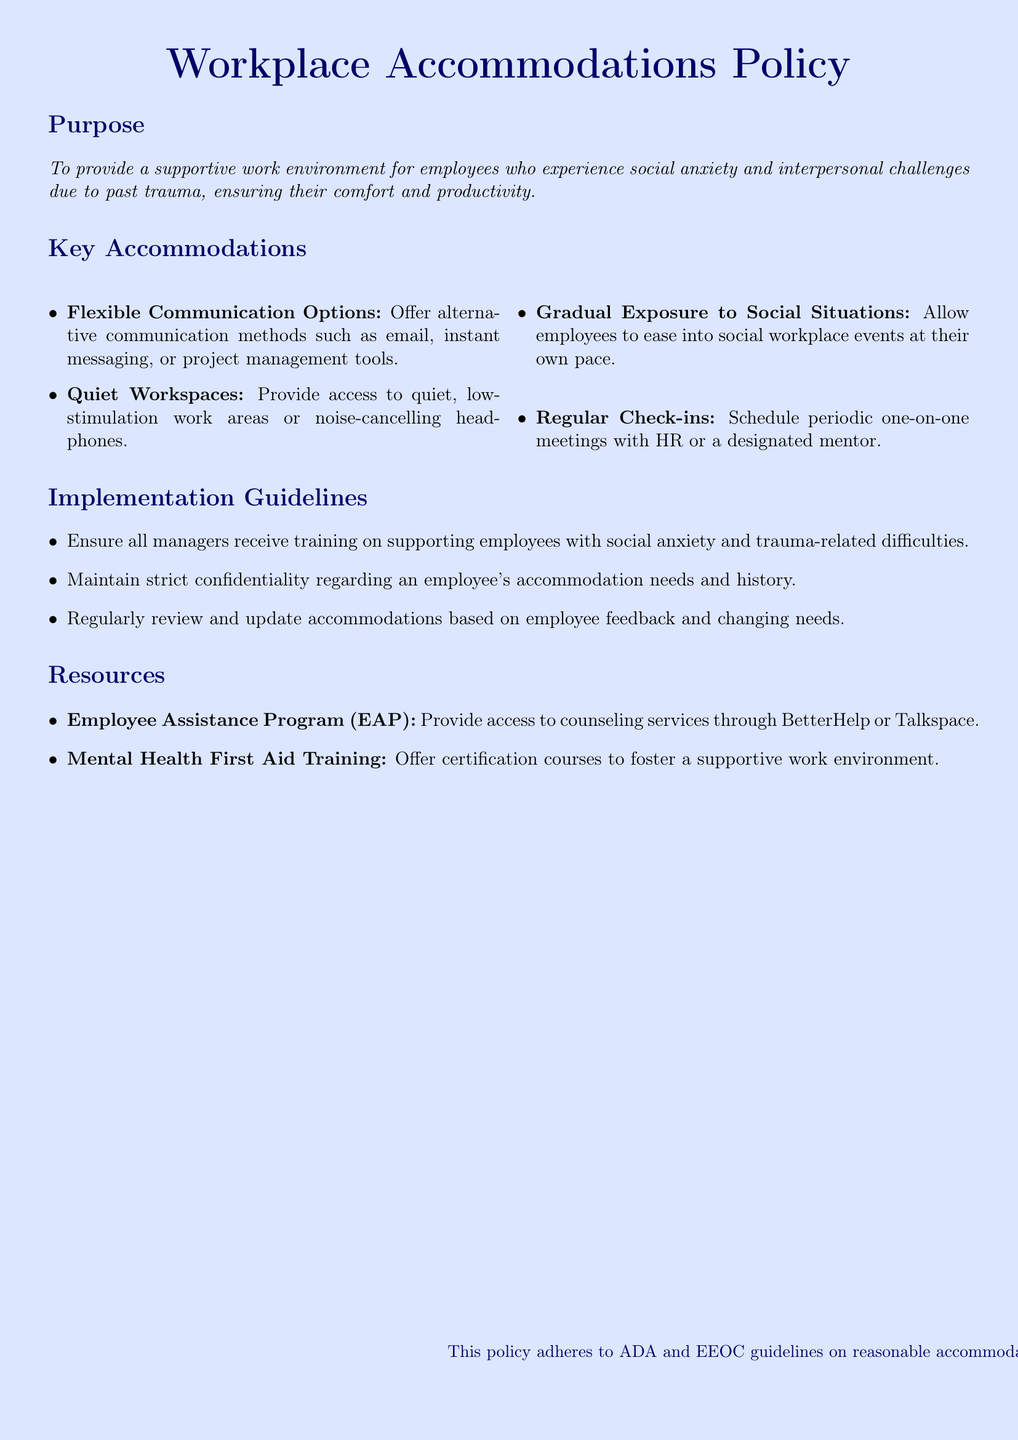What is the purpose of the policy? The purpose is to provide a supportive work environment for employees who experience social anxiety and interpersonal challenges due to past trauma, ensuring their comfort and productivity.
Answer: To provide a supportive work environment for employees who experience social anxiety and interpersonal challenges due to past trauma, ensuring their comfort and productivity What is one key accommodation listed in the document? The document lists several accommodations; one example is providing access to quiet, low-stimulation work areas or noise-cancelling headphones.
Answer: Quiet Workspaces How many types of communication options are offered? The document mentions alternative communication methods such as email, instant messaging, or project management tools. Although it does not specify a number, it implies more than one.
Answer: Multiple What should managers receive training on? The policy specifies that all managers should receive training on supporting employees with social anxiety and trauma-related difficulties.
Answer: Supporting employees with social anxiety and trauma-related difficulties What program provides access to counseling services? The document mentions the Employee Assistance Program (EAP) as a resource that provides access to counseling services.
Answer: Employee Assistance Program (EAP) How frequently should regular check-ins occur? The document does not specify an exact frequency for check-ins, only that they should be periodic.
Answer: Periodic Where is mental health training mentioned? The policy mentions mental health first aid training as a resource to foster a supportive work environment.
Answer: Resources What should be maintained strictly according to the guidelines? Confidentiality regarding an employee's accommodation needs and history is emphasized as something that should be maintained strictly.
Answer: Confidentiality 